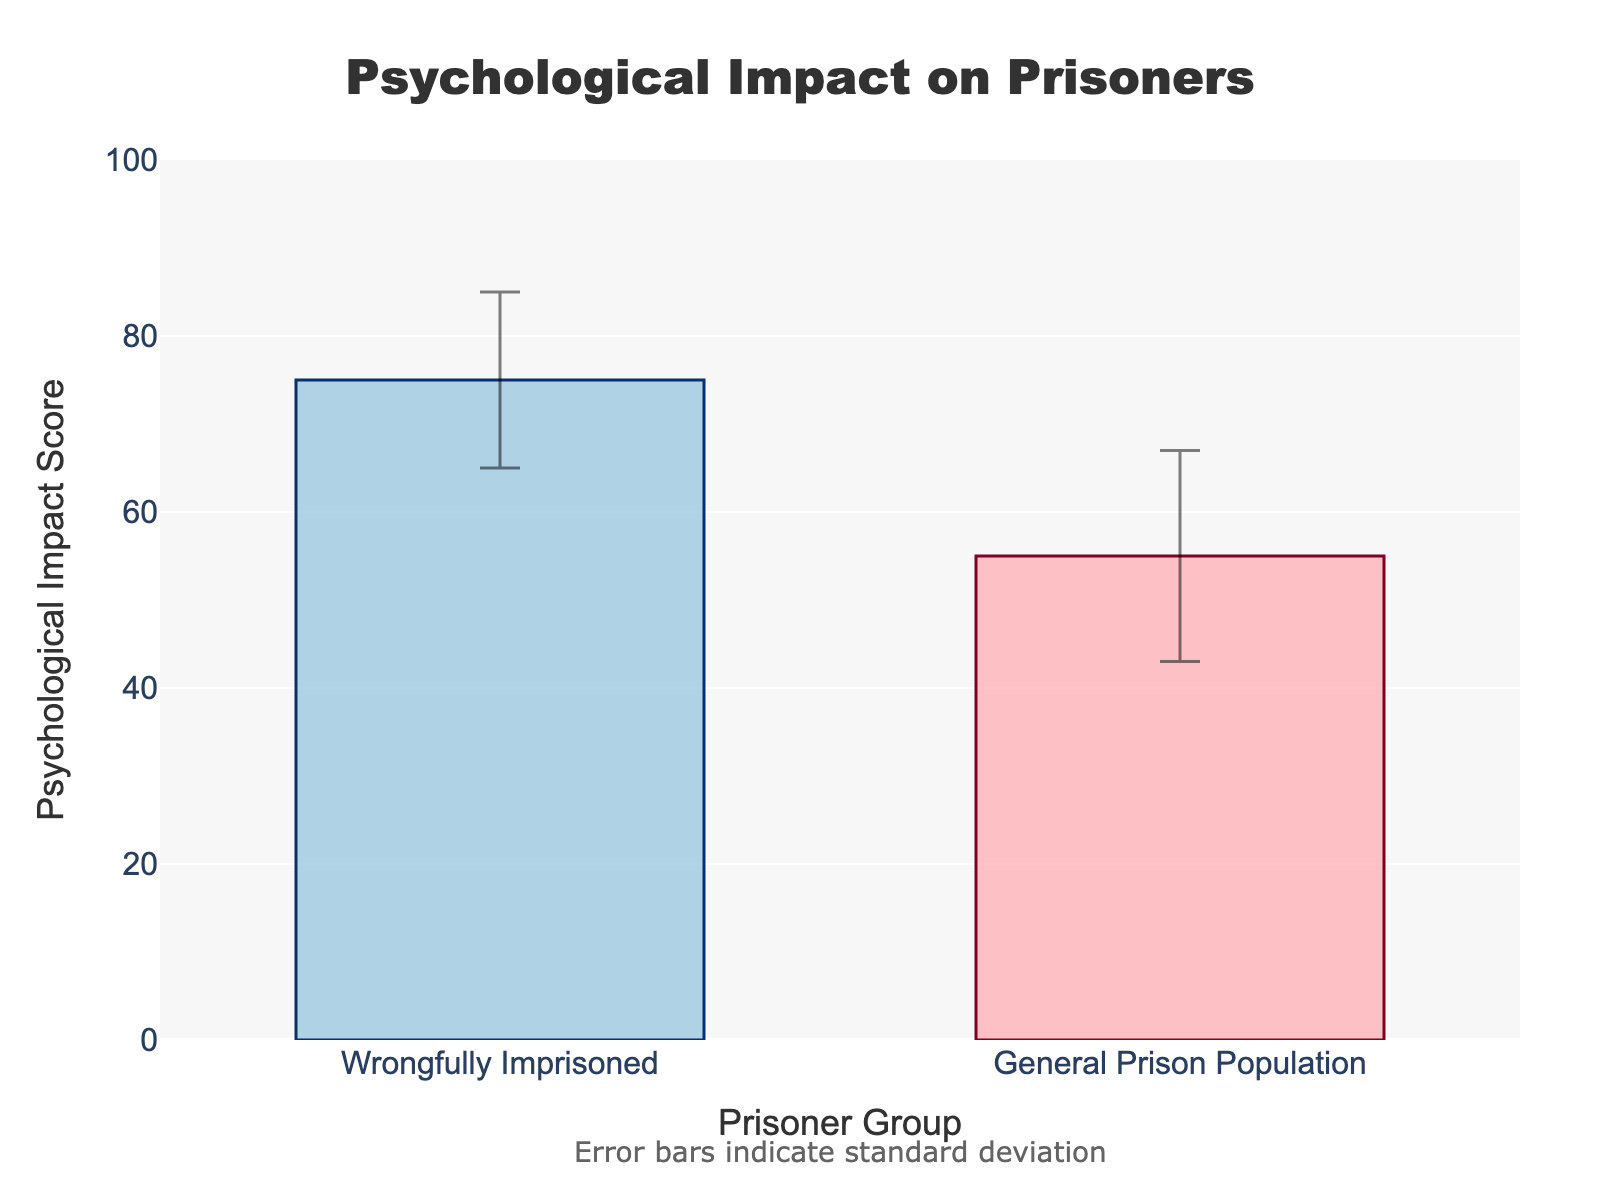What is the title of the plot? The plot has a title that provides a quick summary of what the figure represents. The title is located at the top center of the plot.
Answer: Psychological Impact on Prisoners How many groups are compared in the plot? By looking at the x-axis, we can see that there are labels for two different groups.
Answer: 2 What is the mean psychological impact score for the wrongfully imprisoned group? There is a bar representing the wrongfully imprisoned group, and its height indicates the mean psychological impact score which is labeled directly on the y-axis.
Answer: 75 Which group has a higher psychological impact score? By comparing the heights of the bars representing each group, it is clear that one bar is taller than the other. The taller bar corresponds to the wrongfully imprisoned group.
Answer: Wrongfully Imprisoned What does the error bar represent in this plot? The error bars show the variability of the data; they indicate the standard deviation of the psychological impact scores for each group.
Answer: Standard deviation Which group has a greater variability in psychological impact scores? The length of the error bars represents the standard deviation. Comparing the error bars of both groups, the general prison population has longer error bars indicating greater variability.
Answer: General Prison Population What is the difference in mean psychological impact scores between the two groups? The mean scores for the wrongfully imprisoned group and the general prison population are 75 and 55, respectively. Subtracting these gives the difference.
Answer: 20 What is the range of the y-axis? The y-axis shows the scale for psychological impact scores and the range is provided from 0 to 100.
Answer: 0 to 100 How do the standard deviations compare between the two groups? By looking at the error bars' sizes, we can compare the lengths, which indicate the standard deviations of 10 for the wrongfully imprisoned and 12 for the general prison population. The general prison population has a larger standard deviation.
Answer: General Prison Population has a larger standard deviation Is there a clear difference in psychological impact scores between the two groups? By comparing the heights of the bars and considering the error bars, there is a notable difference in mean scores (75 vs. 55) with non-overlapping error bars, indicating a clear difference.
Answer: Yes 